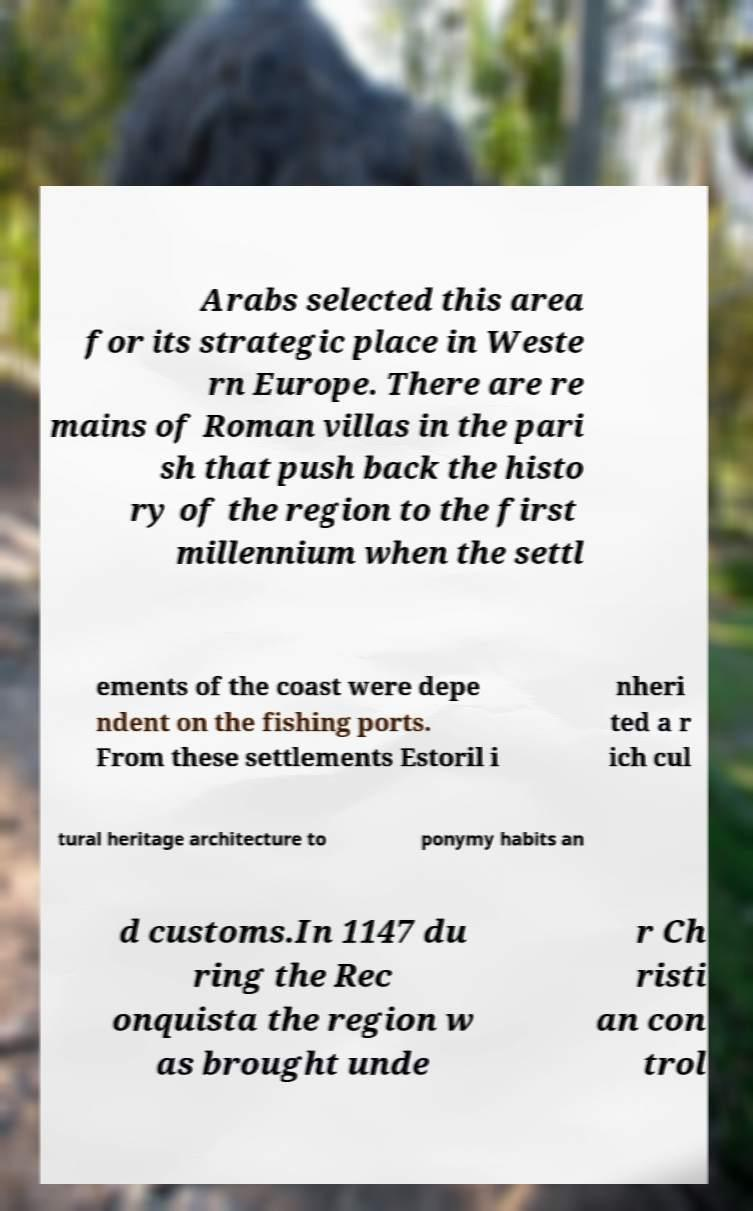There's text embedded in this image that I need extracted. Can you transcribe it verbatim? Arabs selected this area for its strategic place in Weste rn Europe. There are re mains of Roman villas in the pari sh that push back the histo ry of the region to the first millennium when the settl ements of the coast were depe ndent on the fishing ports. From these settlements Estoril i nheri ted a r ich cul tural heritage architecture to ponymy habits an d customs.In 1147 du ring the Rec onquista the region w as brought unde r Ch risti an con trol 